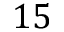<formula> <loc_0><loc_0><loc_500><loc_500>1 5</formula> 